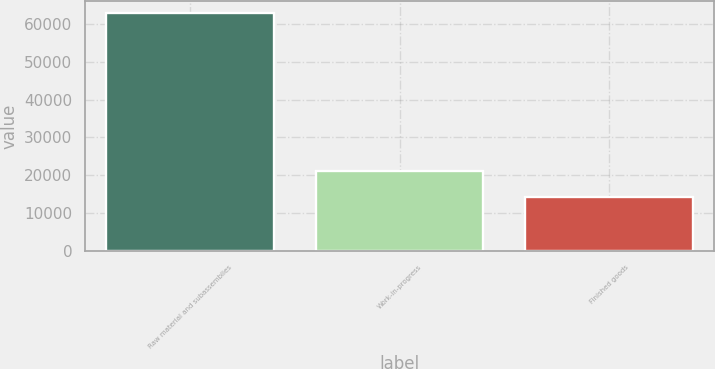<chart> <loc_0><loc_0><loc_500><loc_500><bar_chart><fcel>Raw material and subassemblies<fcel>Work-in-progress<fcel>Finished goods<nl><fcel>62906<fcel>21181<fcel>14171<nl></chart> 